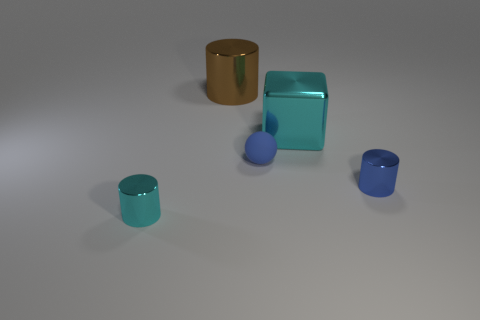Is there any other thing that is the same color as the rubber sphere?
Keep it short and to the point. Yes. There is a cyan thing on the right side of the cyan metal cylinder; what is its material?
Offer a terse response. Metal. Do the cyan shiny block and the blue cylinder have the same size?
Provide a succinct answer. No. How many other objects are the same size as the shiny block?
Provide a short and direct response. 1. Is the color of the metal cube the same as the rubber sphere?
Offer a very short reply. No. What is the shape of the small shiny object on the left side of the tiny metallic object right of the cyan shiny thing right of the small cyan object?
Offer a terse response. Cylinder. What number of objects are small things that are on the left side of the small blue shiny object or small shiny cylinders to the right of the matte ball?
Provide a short and direct response. 3. There is a cyan shiny object that is on the right side of the cylinder to the left of the brown cylinder; what size is it?
Ensure brevity in your answer.  Large. Is the color of the small metallic object that is in front of the tiny blue cylinder the same as the shiny cube?
Give a very brief answer. Yes. Is there another large brown metal object that has the same shape as the big brown thing?
Give a very brief answer. No. 